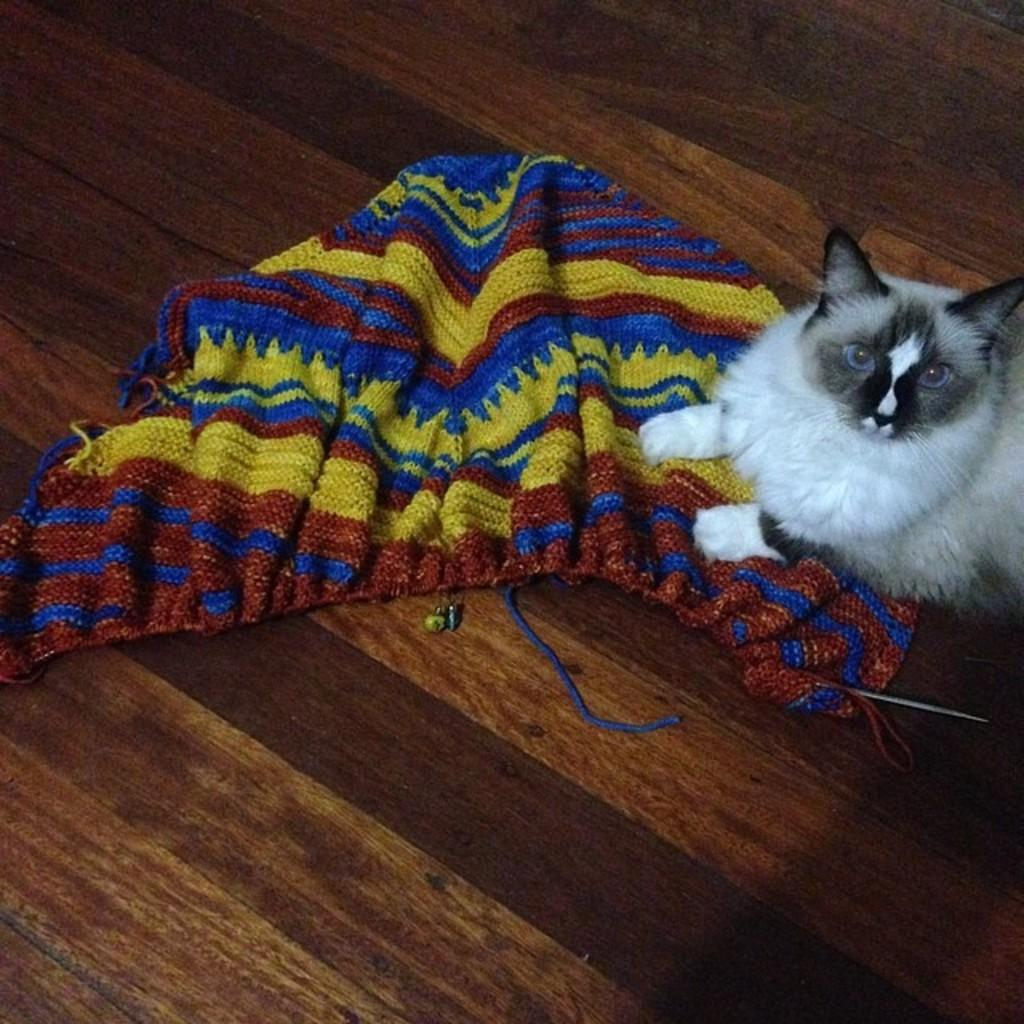What type of flooring is visible in the image? There is a wooden floor in the image. What animal can be seen on the floor? There is a cat on the floor. What type of material is the cloth on the floor made of? The cloth on the floor is made of wool. What type of discussion is taking place in the image? There is no discussion taking place in the image; it only shows a cat on a wooden floor with a woolen cloth. What type of art is displayed in the image? There is no art displayed in the image; it only shows a cat, a wooden floor, and a woolen cloth. 